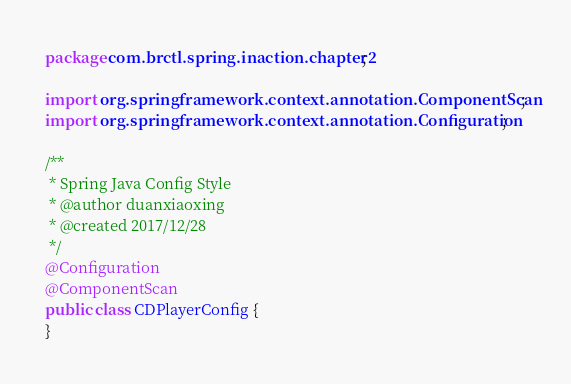<code> <loc_0><loc_0><loc_500><loc_500><_Java_>package com.brctl.spring.inaction.chapter2;

import org.springframework.context.annotation.ComponentScan;
import org.springframework.context.annotation.Configuration;

/**
 * Spring Java Config Style
 * @author duanxiaoxing
 * @created 2017/12/28
 */
@Configuration
@ComponentScan
public class CDPlayerConfig {
}
</code> 